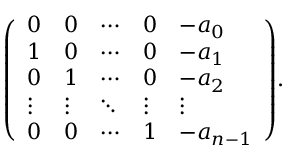<formula> <loc_0><loc_0><loc_500><loc_500>{ \left ( \begin{array} { l l l l l } { 0 } & { 0 } & { \cdots } & { 0 } & { - a _ { 0 } } \\ { 1 } & { 0 } & { \cdots } & { 0 } & { - a _ { 1 } } \\ { 0 } & { 1 } & { \cdots } & { 0 } & { - a _ { 2 } } \\ { \vdots } & { \vdots } & { \ddots } & { \vdots } & { \vdots } \\ { 0 } & { 0 } & { \cdots } & { 1 } & { - a _ { n - 1 } } \end{array} \right ) } .</formula> 